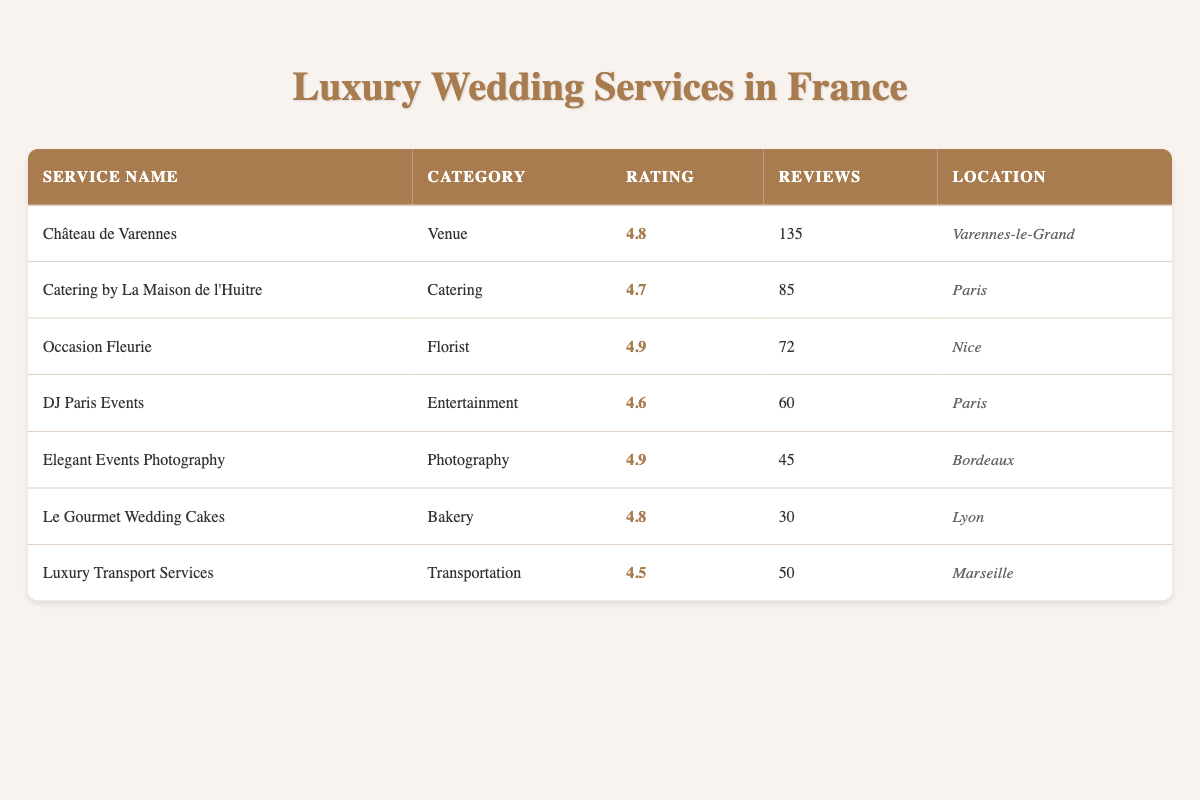What is the average rating of the catering service? The catering service, "Catering by La Maison de l'Huitre," has an average rating of 4.7 according to the table.
Answer: 4.7 Which luxury wedding service has the highest number of reviews? Referring to the "number of reviews" column in the table, "Château de Varennes" has the highest number of reviews at 135.
Answer: Château de Varennes Is there a florist service listed that has a rating of 4.9? Yes, "Occasion Fleurie" is a florist service that has an average rating of 4.9 as shown in the table.
Answer: Yes What is the total number of reviews for the bakery and photography services combined? The bakery service "Le Gourmet Wedding Cakes" has 30 reviews and the photography service "Elegant Events Photography" has 45 reviews. Adding these together gives 30 + 45 = 75 total reviews.
Answer: 75 Which city has the luxury wedding service with the lowest rating? By examining the "average rating" column, "Luxury Transport Services" in Marseille has the lowest rating of 4.5 compared to the other services listed.
Answer: Marseille How many more reviews does the venue service have compared to the entertainment service? The venue service "Château de Varennes" has 135 reviews and "DJ Paris Events" (entertainment service) has 60 reviews. The difference is 135 - 60 = 75 more reviews.
Answer: 75 Is the average rating of the florist service higher than that of the transportation service? "Occasion Fleurie," the florist, has a rating of 4.9, and "Luxury Transport Services" has a rating of 4.5. Since 4.9 is greater than 4.5, the florist service has a higher rating.
Answer: Yes Which service has a rating of 4.8 and what category does it belong to? The services with a rating of 4.8 are "Château de Varennes" under the Venue category and "Le Gourmet Wedding Cakes" under the Bakery category.
Answer: Château de Varennes (Venue) and Le Gourmet Wedding Cakes (Bakery) 